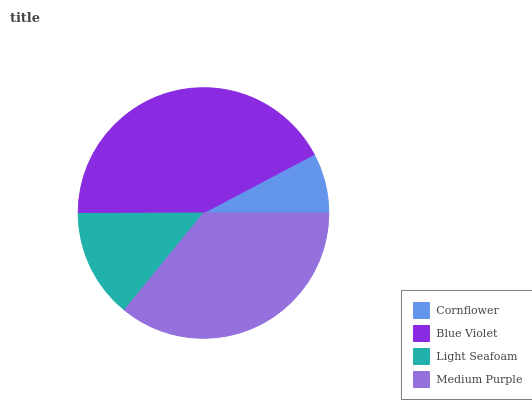Is Cornflower the minimum?
Answer yes or no. Yes. Is Blue Violet the maximum?
Answer yes or no. Yes. Is Light Seafoam the minimum?
Answer yes or no. No. Is Light Seafoam the maximum?
Answer yes or no. No. Is Blue Violet greater than Light Seafoam?
Answer yes or no. Yes. Is Light Seafoam less than Blue Violet?
Answer yes or no. Yes. Is Light Seafoam greater than Blue Violet?
Answer yes or no. No. Is Blue Violet less than Light Seafoam?
Answer yes or no. No. Is Medium Purple the high median?
Answer yes or no. Yes. Is Light Seafoam the low median?
Answer yes or no. Yes. Is Light Seafoam the high median?
Answer yes or no. No. Is Cornflower the low median?
Answer yes or no. No. 